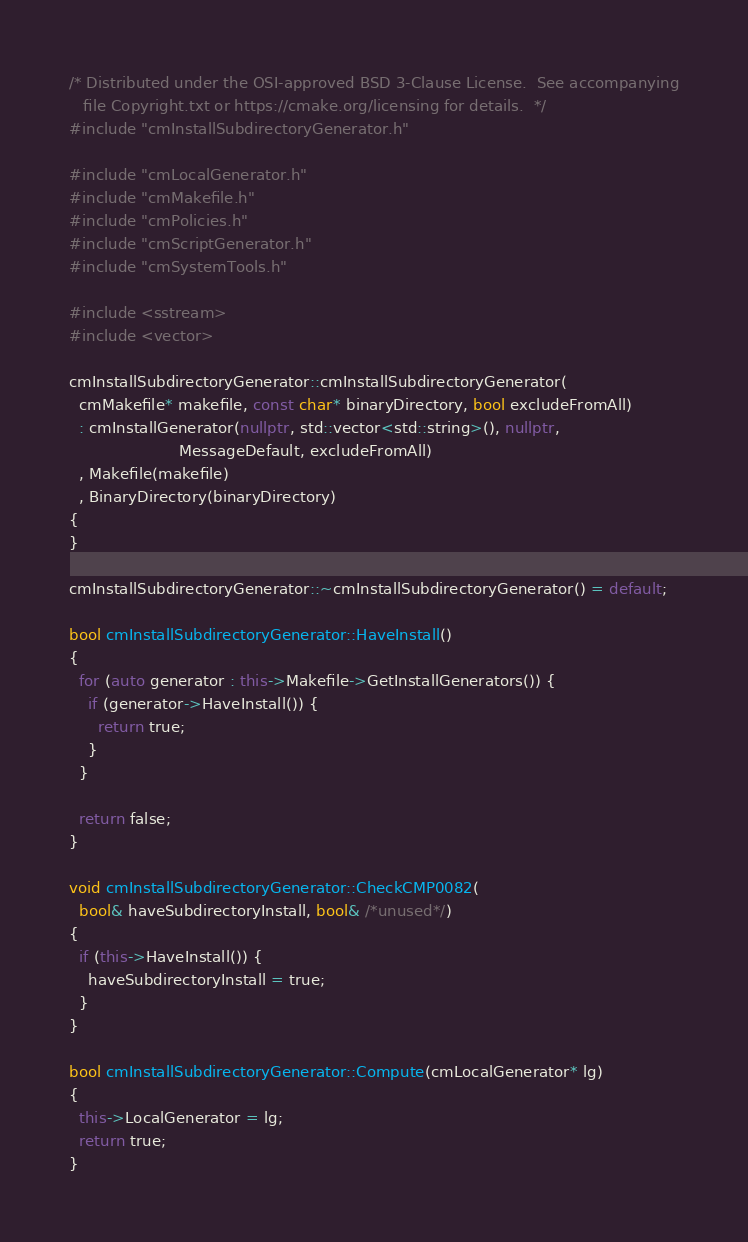<code> <loc_0><loc_0><loc_500><loc_500><_C++_>/* Distributed under the OSI-approved BSD 3-Clause License.  See accompanying
   file Copyright.txt or https://cmake.org/licensing for details.  */
#include "cmInstallSubdirectoryGenerator.h"

#include "cmLocalGenerator.h"
#include "cmMakefile.h"
#include "cmPolicies.h"
#include "cmScriptGenerator.h"
#include "cmSystemTools.h"

#include <sstream>
#include <vector>

cmInstallSubdirectoryGenerator::cmInstallSubdirectoryGenerator(
  cmMakefile* makefile, const char* binaryDirectory, bool excludeFromAll)
  : cmInstallGenerator(nullptr, std::vector<std::string>(), nullptr,
                       MessageDefault, excludeFromAll)
  , Makefile(makefile)
  , BinaryDirectory(binaryDirectory)
{
}

cmInstallSubdirectoryGenerator::~cmInstallSubdirectoryGenerator() = default;

bool cmInstallSubdirectoryGenerator::HaveInstall()
{
  for (auto generator : this->Makefile->GetInstallGenerators()) {
    if (generator->HaveInstall()) {
      return true;
    }
  }

  return false;
}

void cmInstallSubdirectoryGenerator::CheckCMP0082(
  bool& haveSubdirectoryInstall, bool& /*unused*/)
{
  if (this->HaveInstall()) {
    haveSubdirectoryInstall = true;
  }
}

bool cmInstallSubdirectoryGenerator::Compute(cmLocalGenerator* lg)
{
  this->LocalGenerator = lg;
  return true;
}
</code> 